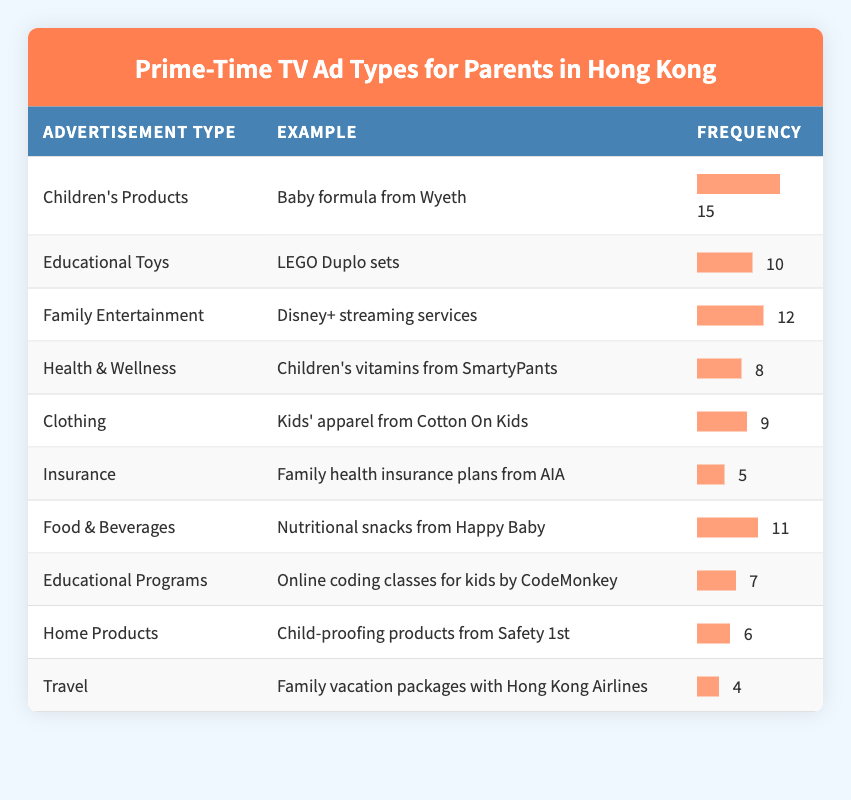What is the most frequently seen advertisement type during prime-time? The frequency column indicates the number of times each type of advertisement was seen. The highest frequency is 15, associated with "Children's Products," specifically "Baby formula from Wyeth."
Answer: Children's Products How many advertisements are shown for "Health & Wellness"? Looking at the table, the frequency for "Health & Wellness," which features "Children's vitamins from SmartyPants," is 8.
Answer: 8 What is the frequency of advertisements for "Travel"? In the table, "Travel," represented by "Family vacation packages with Hong Kong Airlines," has a frequency of 4.
Answer: 4 What percentage of advertisements are for "Insurance"? The frequency of advertisements for "Insurance" is 5 out of a total of 15 (15 + 10 + 12 + 8 + 9 + 5 + 11 + 7 + 6 + 4 = 87). The percentage is calculated as (5 / 87) * 100 = approximately 5.75%.
Answer: 5.75% Is "Educational Programs" more frequently advertised than "Food & Beverages"? The frequency for "Educational Programs" is 7, whereas "Food & Beverages" has a frequency of 11. Thus, "Educational Programs" is advertised less often than "Food & Beverages."
Answer: No What is the total frequency of advertisements for "Clothing," "Food & Beverages," and "Health & Wellness"? From the table, the frequency for "Clothing" is 9, "Food & Beverages" is 11, and "Health & Wellness" is 8. Adding these gives: 9 + 11 + 8 = 28.
Answer: 28 Which advertisement type appears the least often? The frequency for "Travel" is 4, which is the lowest compared to other advertisement types listed.
Answer: Travel What is the difference in frequency between the most frequently and least frequently advertised types? The most frequently advertised type is "Children's Products" at 15, and the least is "Travel" at 4. The difference between these frequencies is 15 - 4 = 11.
Answer: 11 What is the average frequency of all advertisement types? There are 10 advertisement types, and their total frequency is 87. To find the average, divide the total frequency by the number of types: 87 / 10 = 8.7.
Answer: 8.7 